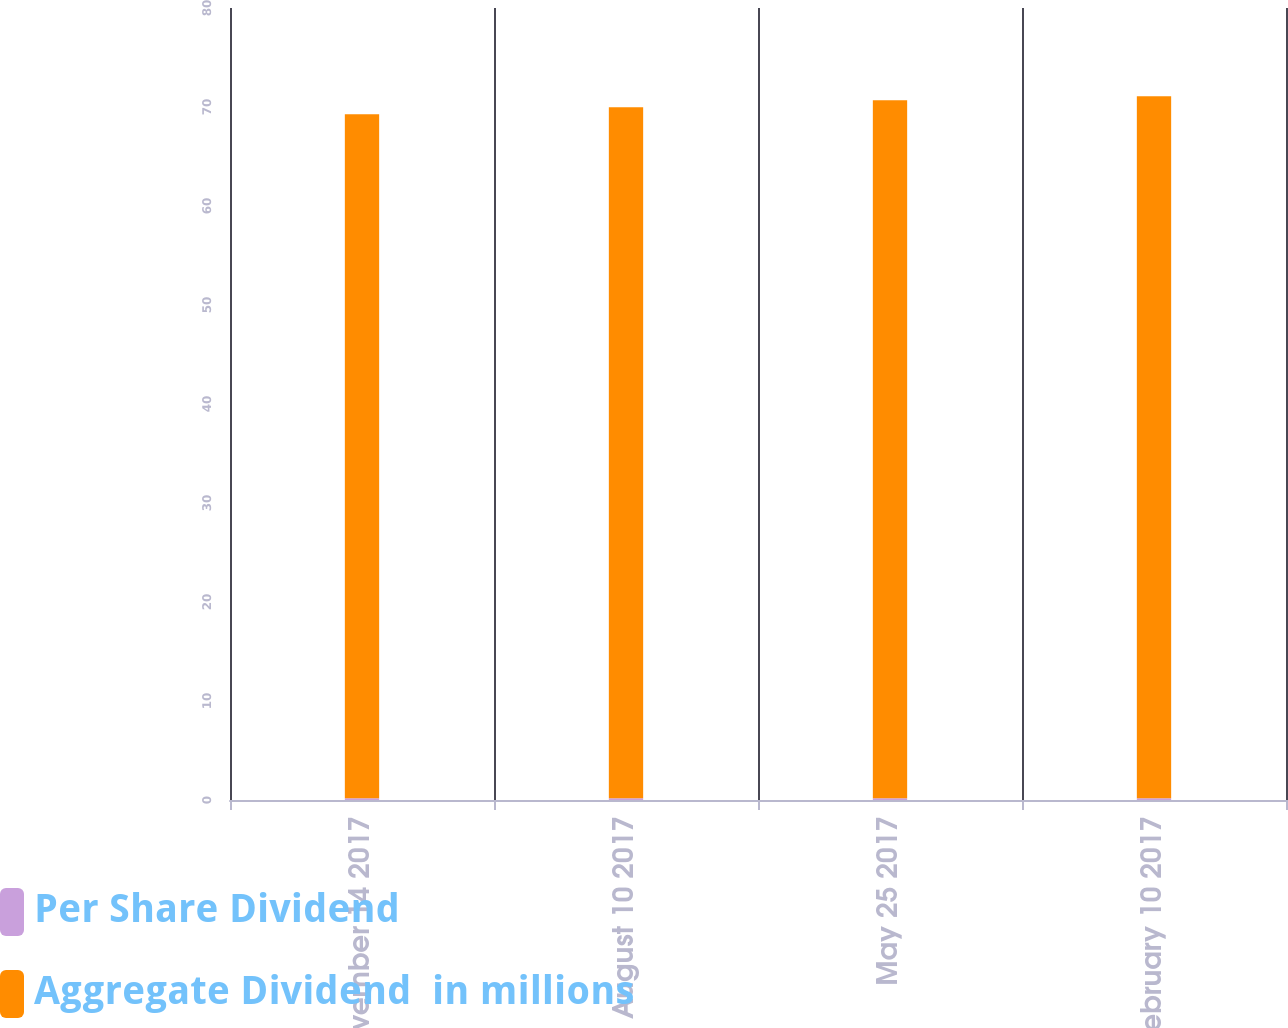Convert chart to OTSL. <chart><loc_0><loc_0><loc_500><loc_500><stacked_bar_chart><ecel><fcel>November 14 2017<fcel>August 10 2017<fcel>May 25 2017<fcel>February 10 2017<nl><fcel>Per Share Dividend<fcel>0.18<fcel>0.18<fcel>0.18<fcel>0.18<nl><fcel>Aggregate Dividend  in millions<fcel>69.1<fcel>69.8<fcel>70.5<fcel>70.9<nl></chart> 